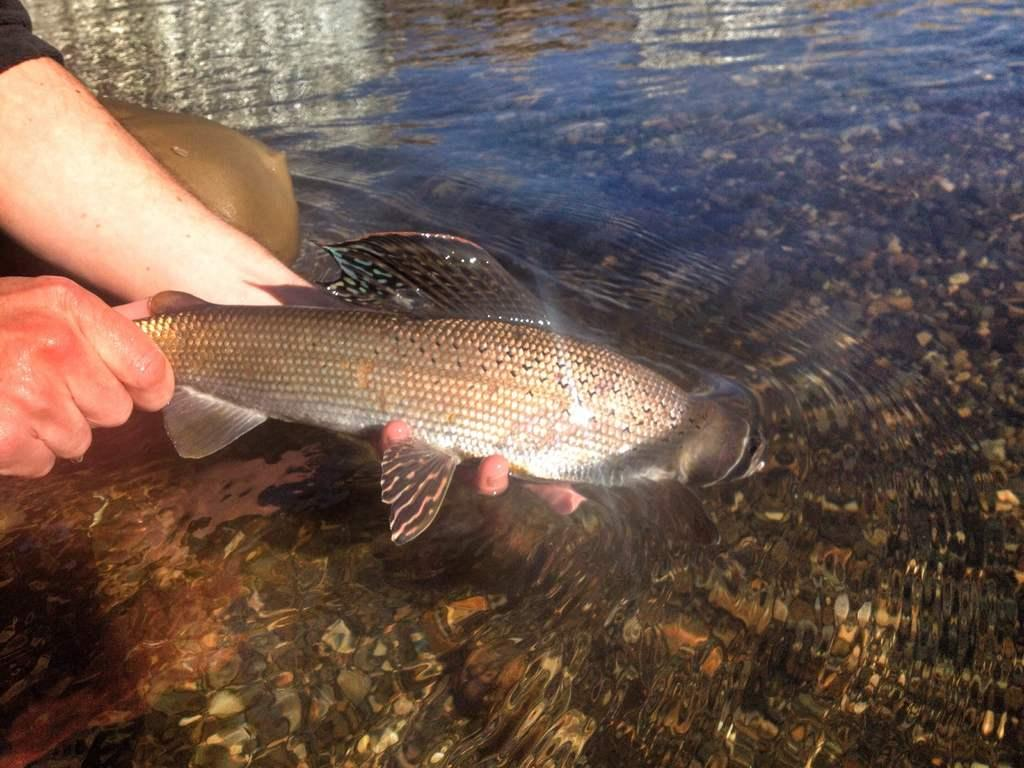Who is present on the left side of the image? There is a person on the left side of the image. What is the person holding in the image? The person is holding a fish. How is the fish positioned in relation to the water? The fish is partially in the water. What can be seen on the right side of the image? There are stones and shells on the right side of the image. Where are the stones and shells located? The stones and shells are in the underground of the water. What organization is responsible for the gun in the image? There is no gun present in the image. Can you compare the size of the fish to the size of the shells in the image? The size of the fish cannot be compared to the size of the shells in the image, as the size of the shells is not mentioned in the provided facts. 